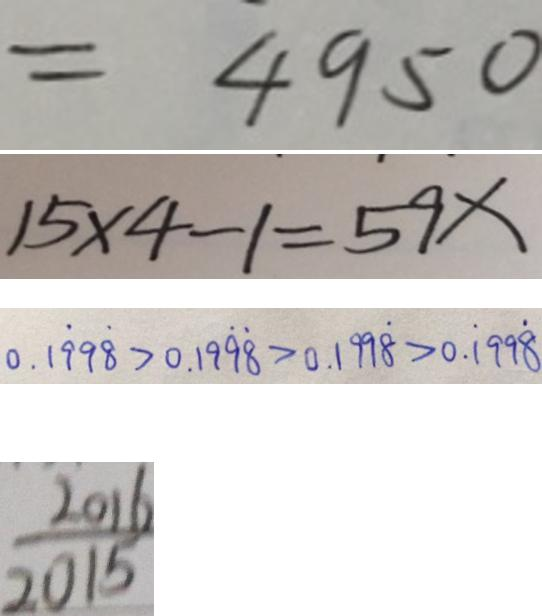<formula> <loc_0><loc_0><loc_500><loc_500>= 4 9 5 0 
 1 5 \times 4 - 1 = 5 9 x 
 0 . 1 \dot { 9 } 9 \dot { 8 } > 0 . 1 9 \dot { 9 } \dot { 8 } > 0 . 1 9 9 \dot { 8 } > 0 . \dot { 1 } 9 9 \dot { 8 } 
 \frac { 2 0 1 6 } { 2 0 1 5 }</formula> 